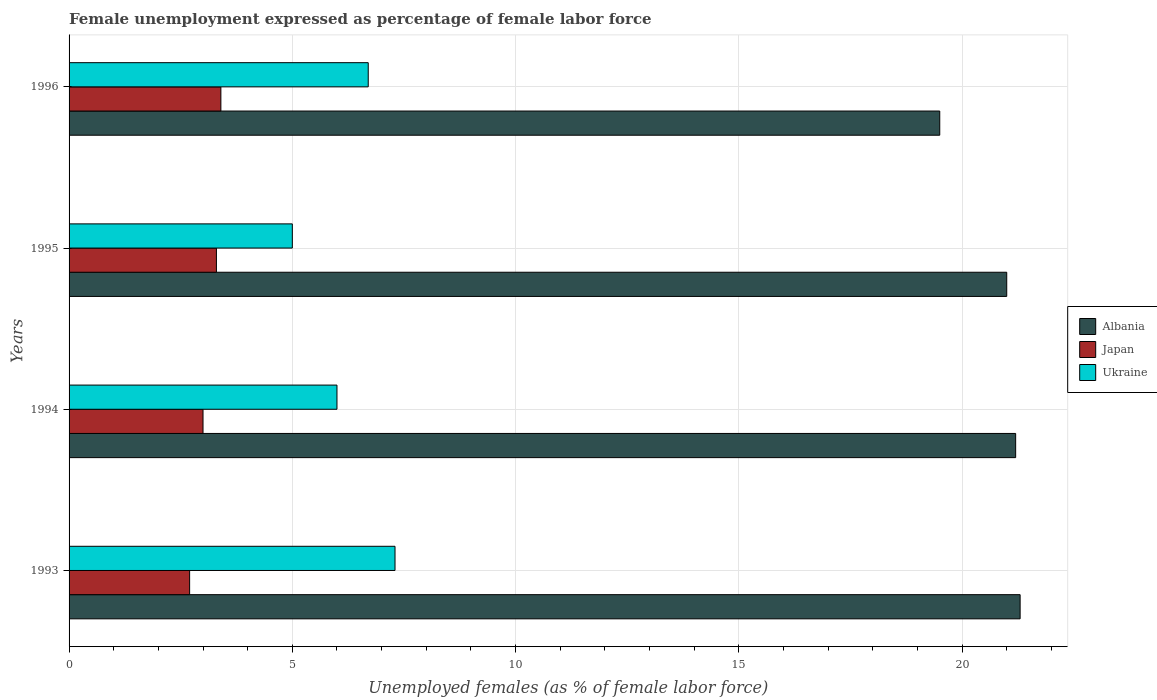How many groups of bars are there?
Provide a short and direct response. 4. Are the number of bars on each tick of the Y-axis equal?
Provide a succinct answer. Yes. What is the label of the 2nd group of bars from the top?
Offer a terse response. 1995. What is the unemployment in females in in Albania in 1993?
Your answer should be very brief. 21.3. Across all years, what is the maximum unemployment in females in in Albania?
Provide a succinct answer. 21.3. Across all years, what is the minimum unemployment in females in in Japan?
Your answer should be very brief. 2.7. What is the total unemployment in females in in Japan in the graph?
Keep it short and to the point. 12.4. What is the difference between the unemployment in females in in Ukraine in 1994 and that in 1996?
Provide a short and direct response. -0.7. What is the average unemployment in females in in Albania per year?
Offer a terse response. 20.75. In how many years, is the unemployment in females in in Ukraine greater than 21 %?
Your answer should be very brief. 0. What is the ratio of the unemployment in females in in Japan in 1995 to that in 1996?
Give a very brief answer. 0.97. What is the difference between the highest and the second highest unemployment in females in in Japan?
Your answer should be very brief. 0.1. What is the difference between the highest and the lowest unemployment in females in in Ukraine?
Give a very brief answer. 2.3. What does the 2nd bar from the top in 1993 represents?
Provide a short and direct response. Japan. Is it the case that in every year, the sum of the unemployment in females in in Ukraine and unemployment in females in in Albania is greater than the unemployment in females in in Japan?
Offer a terse response. Yes. Are all the bars in the graph horizontal?
Ensure brevity in your answer.  Yes. Are the values on the major ticks of X-axis written in scientific E-notation?
Offer a terse response. No. Does the graph contain any zero values?
Give a very brief answer. No. Where does the legend appear in the graph?
Give a very brief answer. Center right. How are the legend labels stacked?
Offer a very short reply. Vertical. What is the title of the graph?
Your response must be concise. Female unemployment expressed as percentage of female labor force. Does "New Caledonia" appear as one of the legend labels in the graph?
Keep it short and to the point. No. What is the label or title of the X-axis?
Keep it short and to the point. Unemployed females (as % of female labor force). What is the label or title of the Y-axis?
Your answer should be very brief. Years. What is the Unemployed females (as % of female labor force) of Albania in 1993?
Ensure brevity in your answer.  21.3. What is the Unemployed females (as % of female labor force) of Japan in 1993?
Your response must be concise. 2.7. What is the Unemployed females (as % of female labor force) of Ukraine in 1993?
Provide a short and direct response. 7.3. What is the Unemployed females (as % of female labor force) of Albania in 1994?
Make the answer very short. 21.2. What is the Unemployed females (as % of female labor force) of Japan in 1994?
Keep it short and to the point. 3. What is the Unemployed females (as % of female labor force) of Albania in 1995?
Make the answer very short. 21. What is the Unemployed females (as % of female labor force) in Japan in 1995?
Ensure brevity in your answer.  3.3. What is the Unemployed females (as % of female labor force) of Japan in 1996?
Your answer should be very brief. 3.4. What is the Unemployed females (as % of female labor force) of Ukraine in 1996?
Your answer should be very brief. 6.7. Across all years, what is the maximum Unemployed females (as % of female labor force) in Albania?
Make the answer very short. 21.3. Across all years, what is the maximum Unemployed females (as % of female labor force) in Japan?
Your response must be concise. 3.4. Across all years, what is the maximum Unemployed females (as % of female labor force) of Ukraine?
Your answer should be compact. 7.3. Across all years, what is the minimum Unemployed females (as % of female labor force) in Albania?
Keep it short and to the point. 19.5. Across all years, what is the minimum Unemployed females (as % of female labor force) of Japan?
Provide a short and direct response. 2.7. Across all years, what is the minimum Unemployed females (as % of female labor force) of Ukraine?
Provide a short and direct response. 5. What is the total Unemployed females (as % of female labor force) of Albania in the graph?
Ensure brevity in your answer.  83. What is the total Unemployed females (as % of female labor force) of Japan in the graph?
Offer a terse response. 12.4. What is the difference between the Unemployed females (as % of female labor force) of Japan in 1993 and that in 1994?
Your answer should be very brief. -0.3. What is the difference between the Unemployed females (as % of female labor force) of Ukraine in 1993 and that in 1995?
Ensure brevity in your answer.  2.3. What is the difference between the Unemployed females (as % of female labor force) of Japan in 1993 and that in 1996?
Offer a very short reply. -0.7. What is the difference between the Unemployed females (as % of female labor force) of Albania in 1994 and that in 1995?
Provide a succinct answer. 0.2. What is the difference between the Unemployed females (as % of female labor force) in Ukraine in 1994 and that in 1995?
Offer a very short reply. 1. What is the difference between the Unemployed females (as % of female labor force) of Albania in 1994 and that in 1996?
Keep it short and to the point. 1.7. What is the difference between the Unemployed females (as % of female labor force) in Japan in 1994 and that in 1996?
Your answer should be compact. -0.4. What is the difference between the Unemployed females (as % of female labor force) in Ukraine in 1995 and that in 1996?
Offer a very short reply. -1.7. What is the difference between the Unemployed females (as % of female labor force) in Albania in 1993 and the Unemployed females (as % of female labor force) in Ukraine in 1994?
Offer a terse response. 15.3. What is the difference between the Unemployed females (as % of female labor force) of Japan in 1993 and the Unemployed females (as % of female labor force) of Ukraine in 1994?
Your answer should be compact. -3.3. What is the difference between the Unemployed females (as % of female labor force) of Albania in 1993 and the Unemployed females (as % of female labor force) of Japan in 1995?
Offer a very short reply. 18. What is the difference between the Unemployed females (as % of female labor force) of Japan in 1993 and the Unemployed females (as % of female labor force) of Ukraine in 1995?
Your response must be concise. -2.3. What is the difference between the Unemployed females (as % of female labor force) in Albania in 1994 and the Unemployed females (as % of female labor force) in Japan in 1995?
Your answer should be compact. 17.9. What is the difference between the Unemployed females (as % of female labor force) in Albania in 1994 and the Unemployed females (as % of female labor force) in Ukraine in 1995?
Offer a terse response. 16.2. What is the difference between the Unemployed females (as % of female labor force) in Japan in 1994 and the Unemployed females (as % of female labor force) in Ukraine in 1995?
Offer a terse response. -2. What is the difference between the Unemployed females (as % of female labor force) of Albania in 1994 and the Unemployed females (as % of female labor force) of Japan in 1996?
Ensure brevity in your answer.  17.8. What is the difference between the Unemployed females (as % of female labor force) in Japan in 1994 and the Unemployed females (as % of female labor force) in Ukraine in 1996?
Your answer should be compact. -3.7. What is the difference between the Unemployed females (as % of female labor force) in Albania in 1995 and the Unemployed females (as % of female labor force) in Japan in 1996?
Give a very brief answer. 17.6. What is the difference between the Unemployed females (as % of female labor force) in Albania in 1995 and the Unemployed females (as % of female labor force) in Ukraine in 1996?
Offer a terse response. 14.3. What is the difference between the Unemployed females (as % of female labor force) in Japan in 1995 and the Unemployed females (as % of female labor force) in Ukraine in 1996?
Give a very brief answer. -3.4. What is the average Unemployed females (as % of female labor force) of Albania per year?
Make the answer very short. 20.75. What is the average Unemployed females (as % of female labor force) of Ukraine per year?
Offer a terse response. 6.25. In the year 1993, what is the difference between the Unemployed females (as % of female labor force) of Albania and Unemployed females (as % of female labor force) of Japan?
Your answer should be compact. 18.6. In the year 1994, what is the difference between the Unemployed females (as % of female labor force) in Albania and Unemployed females (as % of female labor force) in Ukraine?
Keep it short and to the point. 15.2. In the year 1994, what is the difference between the Unemployed females (as % of female labor force) of Japan and Unemployed females (as % of female labor force) of Ukraine?
Ensure brevity in your answer.  -3. In the year 1995, what is the difference between the Unemployed females (as % of female labor force) of Albania and Unemployed females (as % of female labor force) of Japan?
Your answer should be very brief. 17.7. In the year 1995, what is the difference between the Unemployed females (as % of female labor force) in Albania and Unemployed females (as % of female labor force) in Ukraine?
Your answer should be very brief. 16. In the year 1996, what is the difference between the Unemployed females (as % of female labor force) in Albania and Unemployed females (as % of female labor force) in Japan?
Your response must be concise. 16.1. What is the ratio of the Unemployed females (as % of female labor force) in Japan in 1993 to that in 1994?
Your response must be concise. 0.9. What is the ratio of the Unemployed females (as % of female labor force) of Ukraine in 1993 to that in 1994?
Provide a short and direct response. 1.22. What is the ratio of the Unemployed females (as % of female labor force) in Albania in 1993 to that in 1995?
Make the answer very short. 1.01. What is the ratio of the Unemployed females (as % of female labor force) in Japan in 1993 to that in 1995?
Provide a short and direct response. 0.82. What is the ratio of the Unemployed females (as % of female labor force) of Ukraine in 1993 to that in 1995?
Your answer should be compact. 1.46. What is the ratio of the Unemployed females (as % of female labor force) of Albania in 1993 to that in 1996?
Your answer should be very brief. 1.09. What is the ratio of the Unemployed females (as % of female labor force) in Japan in 1993 to that in 1996?
Your answer should be very brief. 0.79. What is the ratio of the Unemployed females (as % of female labor force) of Ukraine in 1993 to that in 1996?
Your answer should be very brief. 1.09. What is the ratio of the Unemployed females (as % of female labor force) in Albania in 1994 to that in 1995?
Provide a short and direct response. 1.01. What is the ratio of the Unemployed females (as % of female labor force) of Japan in 1994 to that in 1995?
Your answer should be very brief. 0.91. What is the ratio of the Unemployed females (as % of female labor force) of Albania in 1994 to that in 1996?
Provide a succinct answer. 1.09. What is the ratio of the Unemployed females (as % of female labor force) of Japan in 1994 to that in 1996?
Give a very brief answer. 0.88. What is the ratio of the Unemployed females (as % of female labor force) in Ukraine in 1994 to that in 1996?
Provide a succinct answer. 0.9. What is the ratio of the Unemployed females (as % of female labor force) in Albania in 1995 to that in 1996?
Ensure brevity in your answer.  1.08. What is the ratio of the Unemployed females (as % of female labor force) in Japan in 1995 to that in 1996?
Give a very brief answer. 0.97. What is the ratio of the Unemployed females (as % of female labor force) of Ukraine in 1995 to that in 1996?
Keep it short and to the point. 0.75. What is the difference between the highest and the second highest Unemployed females (as % of female labor force) in Ukraine?
Make the answer very short. 0.6. 